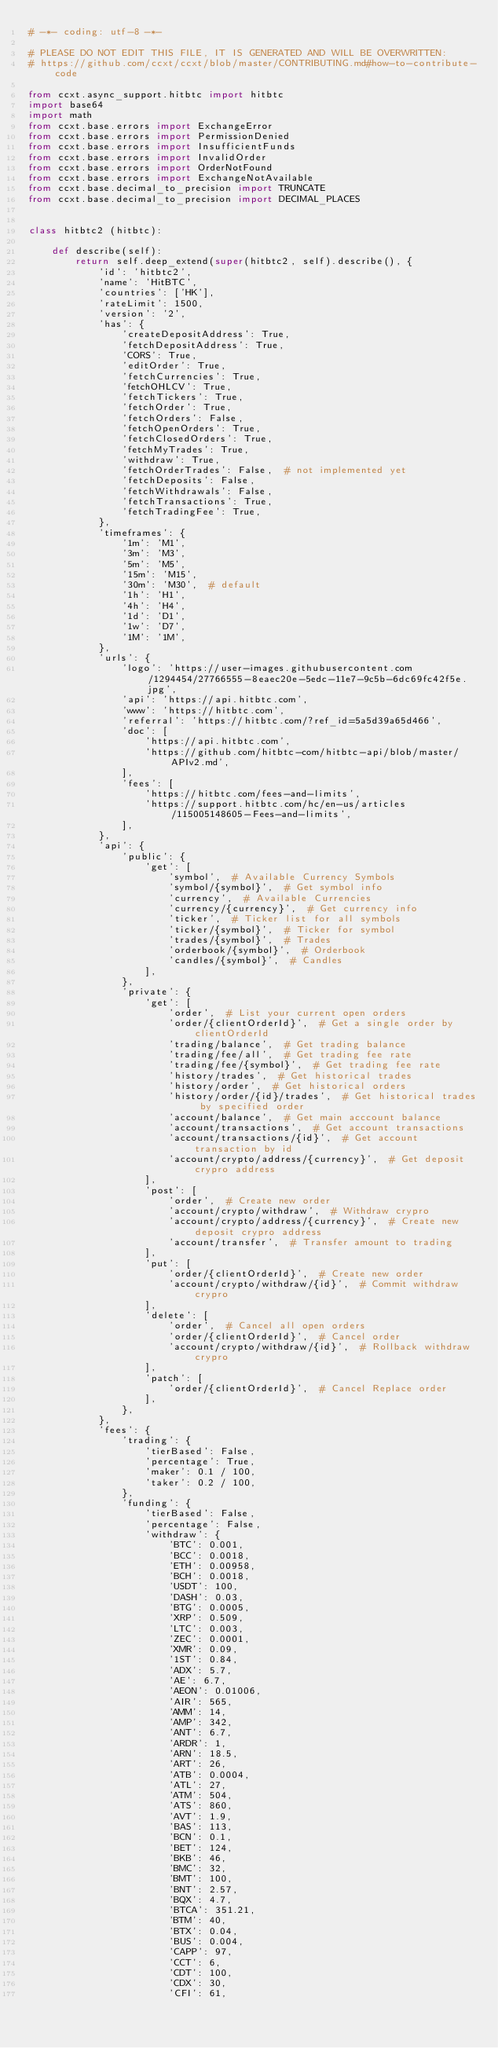Convert code to text. <code><loc_0><loc_0><loc_500><loc_500><_Python_># -*- coding: utf-8 -*-

# PLEASE DO NOT EDIT THIS FILE, IT IS GENERATED AND WILL BE OVERWRITTEN:
# https://github.com/ccxt/ccxt/blob/master/CONTRIBUTING.md#how-to-contribute-code

from ccxt.async_support.hitbtc import hitbtc
import base64
import math
from ccxt.base.errors import ExchangeError
from ccxt.base.errors import PermissionDenied
from ccxt.base.errors import InsufficientFunds
from ccxt.base.errors import InvalidOrder
from ccxt.base.errors import OrderNotFound
from ccxt.base.errors import ExchangeNotAvailable
from ccxt.base.decimal_to_precision import TRUNCATE
from ccxt.base.decimal_to_precision import DECIMAL_PLACES


class hitbtc2 (hitbtc):

    def describe(self):
        return self.deep_extend(super(hitbtc2, self).describe(), {
            'id': 'hitbtc2',
            'name': 'HitBTC',
            'countries': ['HK'],
            'rateLimit': 1500,
            'version': '2',
            'has': {
                'createDepositAddress': True,
                'fetchDepositAddress': True,
                'CORS': True,
                'editOrder': True,
                'fetchCurrencies': True,
                'fetchOHLCV': True,
                'fetchTickers': True,
                'fetchOrder': True,
                'fetchOrders': False,
                'fetchOpenOrders': True,
                'fetchClosedOrders': True,
                'fetchMyTrades': True,
                'withdraw': True,
                'fetchOrderTrades': False,  # not implemented yet
                'fetchDeposits': False,
                'fetchWithdrawals': False,
                'fetchTransactions': True,
                'fetchTradingFee': True,
            },
            'timeframes': {
                '1m': 'M1',
                '3m': 'M3',
                '5m': 'M5',
                '15m': 'M15',
                '30m': 'M30',  # default
                '1h': 'H1',
                '4h': 'H4',
                '1d': 'D1',
                '1w': 'D7',
                '1M': '1M',
            },
            'urls': {
                'logo': 'https://user-images.githubusercontent.com/1294454/27766555-8eaec20e-5edc-11e7-9c5b-6dc69fc42f5e.jpg',
                'api': 'https://api.hitbtc.com',
                'www': 'https://hitbtc.com',
                'referral': 'https://hitbtc.com/?ref_id=5a5d39a65d466',
                'doc': [
                    'https://api.hitbtc.com',
                    'https://github.com/hitbtc-com/hitbtc-api/blob/master/APIv2.md',
                ],
                'fees': [
                    'https://hitbtc.com/fees-and-limits',
                    'https://support.hitbtc.com/hc/en-us/articles/115005148605-Fees-and-limits',
                ],
            },
            'api': {
                'public': {
                    'get': [
                        'symbol',  # Available Currency Symbols
                        'symbol/{symbol}',  # Get symbol info
                        'currency',  # Available Currencies
                        'currency/{currency}',  # Get currency info
                        'ticker',  # Ticker list for all symbols
                        'ticker/{symbol}',  # Ticker for symbol
                        'trades/{symbol}',  # Trades
                        'orderbook/{symbol}',  # Orderbook
                        'candles/{symbol}',  # Candles
                    ],
                },
                'private': {
                    'get': [
                        'order',  # List your current open orders
                        'order/{clientOrderId}',  # Get a single order by clientOrderId
                        'trading/balance',  # Get trading balance
                        'trading/fee/all',  # Get trading fee rate
                        'trading/fee/{symbol}',  # Get trading fee rate
                        'history/trades',  # Get historical trades
                        'history/order',  # Get historical orders
                        'history/order/{id}/trades',  # Get historical trades by specified order
                        'account/balance',  # Get main acccount balance
                        'account/transactions',  # Get account transactions
                        'account/transactions/{id}',  # Get account transaction by id
                        'account/crypto/address/{currency}',  # Get deposit crypro address
                    ],
                    'post': [
                        'order',  # Create new order
                        'account/crypto/withdraw',  # Withdraw crypro
                        'account/crypto/address/{currency}',  # Create new deposit crypro address
                        'account/transfer',  # Transfer amount to trading
                    ],
                    'put': [
                        'order/{clientOrderId}',  # Create new order
                        'account/crypto/withdraw/{id}',  # Commit withdraw crypro
                    ],
                    'delete': [
                        'order',  # Cancel all open orders
                        'order/{clientOrderId}',  # Cancel order
                        'account/crypto/withdraw/{id}',  # Rollback withdraw crypro
                    ],
                    'patch': [
                        'order/{clientOrderId}',  # Cancel Replace order
                    ],
                },
            },
            'fees': {
                'trading': {
                    'tierBased': False,
                    'percentage': True,
                    'maker': 0.1 / 100,
                    'taker': 0.2 / 100,
                },
                'funding': {
                    'tierBased': False,
                    'percentage': False,
                    'withdraw': {
                        'BTC': 0.001,
                        'BCC': 0.0018,
                        'ETH': 0.00958,
                        'BCH': 0.0018,
                        'USDT': 100,
                        'DASH': 0.03,
                        'BTG': 0.0005,
                        'XRP': 0.509,
                        'LTC': 0.003,
                        'ZEC': 0.0001,
                        'XMR': 0.09,
                        '1ST': 0.84,
                        'ADX': 5.7,
                        'AE': 6.7,
                        'AEON': 0.01006,
                        'AIR': 565,
                        'AMM': 14,
                        'AMP': 342,
                        'ANT': 6.7,
                        'ARDR': 1,
                        'ARN': 18.5,
                        'ART': 26,
                        'ATB': 0.0004,
                        'ATL': 27,
                        'ATM': 504,
                        'ATS': 860,
                        'AVT': 1.9,
                        'BAS': 113,
                        'BCN': 0.1,
                        'BET': 124,
                        'BKB': 46,
                        'BMC': 32,
                        'BMT': 100,
                        'BNT': 2.57,
                        'BQX': 4.7,
                        'BTCA': 351.21,
                        'BTM': 40,
                        'BTX': 0.04,
                        'BUS': 0.004,
                        'CAPP': 97,
                        'CCT': 6,
                        'CDT': 100,
                        'CDX': 30,
                        'CFI': 61,</code> 